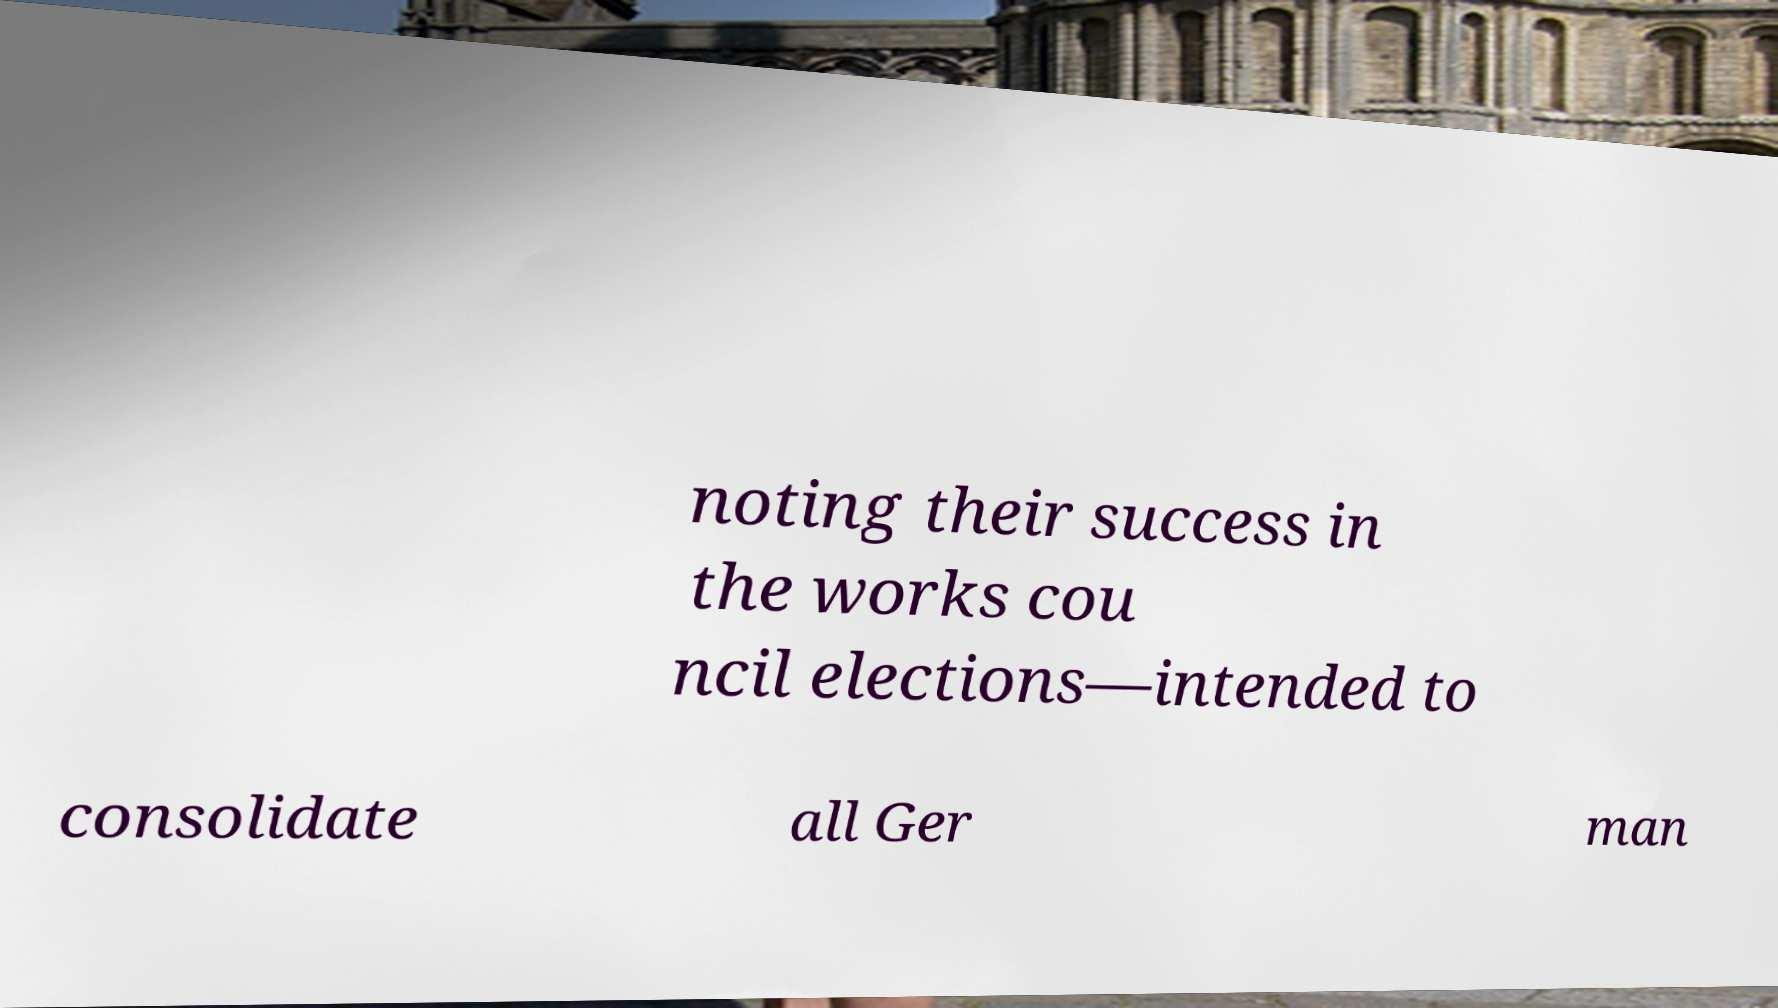Can you read and provide the text displayed in the image?This photo seems to have some interesting text. Can you extract and type it out for me? noting their success in the works cou ncil elections—intended to consolidate all Ger man 